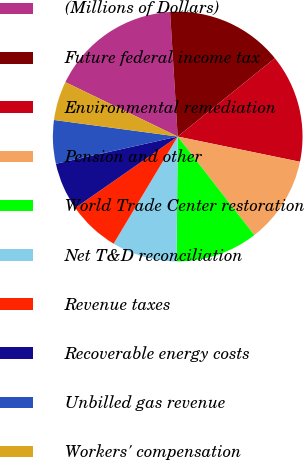Convert chart to OTSL. <chart><loc_0><loc_0><loc_500><loc_500><pie_chart><fcel>(Millions of Dollars)<fcel>Future federal income tax<fcel>Environmental remediation<fcel>Pension and other<fcel>World Trade Center restoration<fcel>Net T&D reconciliation<fcel>Revenue taxes<fcel>Recoverable energy costs<fcel>Unbilled gas revenue<fcel>Workers' compensation<nl><fcel>16.85%<fcel>15.17%<fcel>14.04%<fcel>11.24%<fcel>10.67%<fcel>8.43%<fcel>6.74%<fcel>6.18%<fcel>5.62%<fcel>5.06%<nl></chart> 